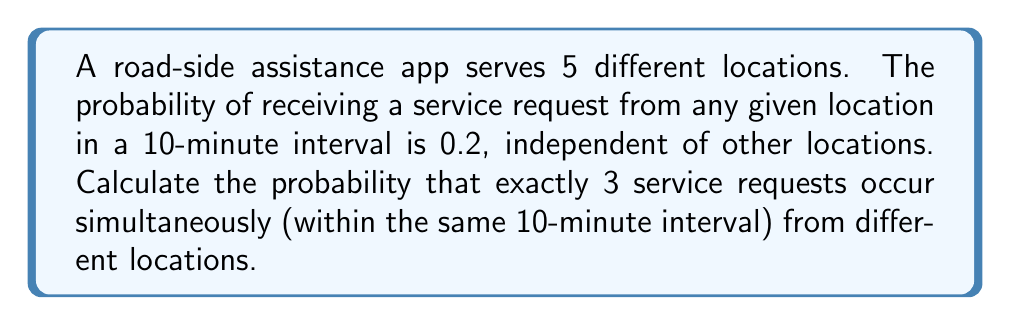Can you solve this math problem? Let's approach this step-by-step:

1) This scenario follows a Binomial distribution, where:
   - $n = 5$ (total number of locations)
   - $p = 0.2$ (probability of a request from each location)
   - $k = 3$ (number of simultaneous requests we're interested in)

2) The probability of exactly $k$ successes in $n$ trials is given by the formula:

   $$P(X = k) = \binom{n}{k} p^k (1-p)^{n-k}$$

3) Let's calculate each part:

   a) $\binom{n}{k} = \binom{5}{3} = \frac{5!}{3!(5-3)!} = \frac{5 \cdot 4}{2 \cdot 1} = 10$

   b) $p^k = 0.2^3 = 0.008$

   c) $(1-p)^{n-k} = 0.8^2 = 0.64$

4) Now, let's put it all together:

   $$P(X = 3) = 10 \cdot 0.008 \cdot 0.64 = 0.0512$$

5) Therefore, the probability of exactly 3 service requests occurring simultaneously from different locations is 0.0512 or 5.12%.
Answer: 0.0512 